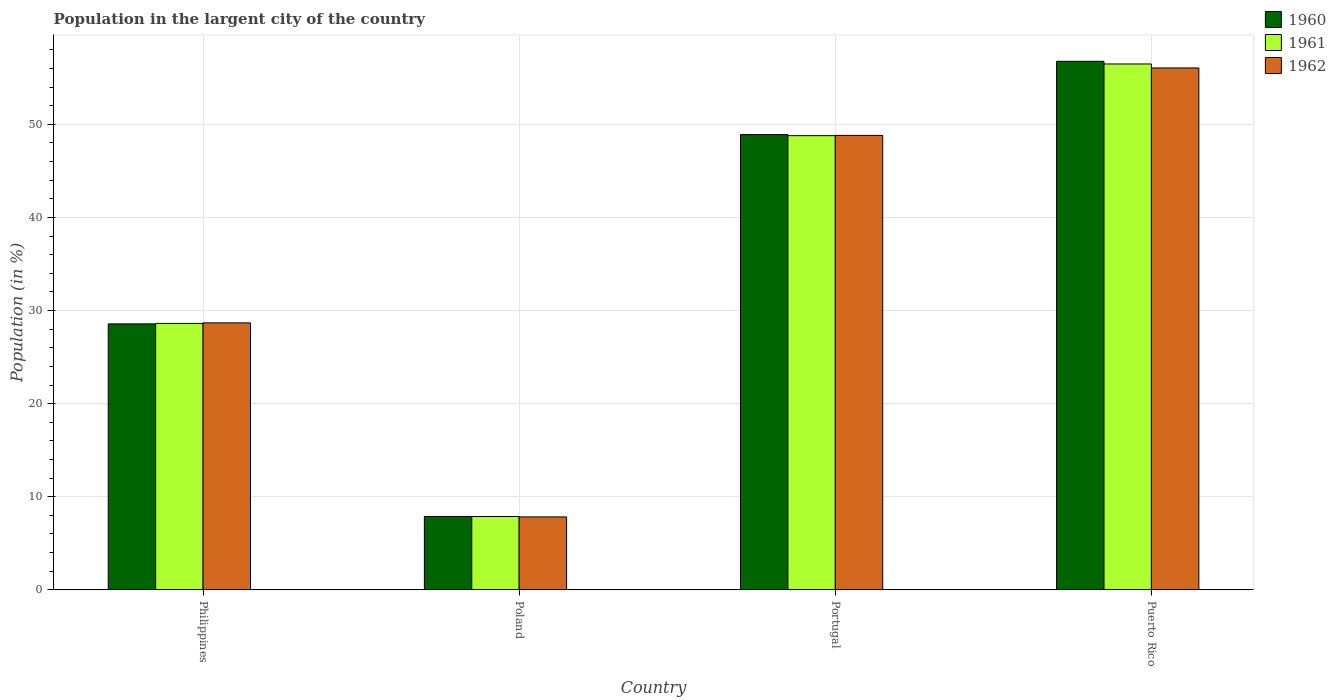How many different coloured bars are there?
Offer a very short reply. 3. How many groups of bars are there?
Offer a terse response. 4. Are the number of bars per tick equal to the number of legend labels?
Your answer should be compact. Yes. What is the label of the 4th group of bars from the left?
Provide a short and direct response. Puerto Rico. What is the percentage of population in the largent city in 1962 in Puerto Rico?
Offer a terse response. 56.05. Across all countries, what is the maximum percentage of population in the largent city in 1960?
Your answer should be very brief. 56.77. Across all countries, what is the minimum percentage of population in the largent city in 1960?
Make the answer very short. 7.88. In which country was the percentage of population in the largent city in 1960 maximum?
Offer a very short reply. Puerto Rico. What is the total percentage of population in the largent city in 1961 in the graph?
Provide a short and direct response. 141.75. What is the difference between the percentage of population in the largent city in 1960 in Portugal and that in Puerto Rico?
Offer a terse response. -7.87. What is the difference between the percentage of population in the largent city in 1960 in Poland and the percentage of population in the largent city in 1962 in Philippines?
Keep it short and to the point. -20.79. What is the average percentage of population in the largent city in 1961 per country?
Keep it short and to the point. 35.44. What is the difference between the percentage of population in the largent city of/in 1960 and percentage of population in the largent city of/in 1961 in Philippines?
Your response must be concise. -0.05. In how many countries, is the percentage of population in the largent city in 1961 greater than 32 %?
Give a very brief answer. 2. What is the ratio of the percentage of population in the largent city in 1961 in Poland to that in Puerto Rico?
Your answer should be compact. 0.14. Is the percentage of population in the largent city in 1960 in Poland less than that in Portugal?
Provide a succinct answer. Yes. Is the difference between the percentage of population in the largent city in 1960 in Poland and Portugal greater than the difference between the percentage of population in the largent city in 1961 in Poland and Portugal?
Offer a very short reply. No. What is the difference between the highest and the second highest percentage of population in the largent city in 1960?
Provide a short and direct response. 7.87. What is the difference between the highest and the lowest percentage of population in the largent city in 1960?
Keep it short and to the point. 48.88. In how many countries, is the percentage of population in the largent city in 1960 greater than the average percentage of population in the largent city in 1960 taken over all countries?
Your answer should be compact. 2. What does the 1st bar from the left in Portugal represents?
Your response must be concise. 1960. What does the 2nd bar from the right in Philippines represents?
Offer a very short reply. 1961. Are all the bars in the graph horizontal?
Offer a terse response. No. Are the values on the major ticks of Y-axis written in scientific E-notation?
Your response must be concise. No. Does the graph contain any zero values?
Offer a terse response. No. Does the graph contain grids?
Your answer should be very brief. Yes. What is the title of the graph?
Offer a terse response. Population in the largent city of the country. What is the Population (in %) of 1960 in Philippines?
Make the answer very short. 28.56. What is the Population (in %) in 1961 in Philippines?
Offer a very short reply. 28.62. What is the Population (in %) of 1962 in Philippines?
Offer a terse response. 28.67. What is the Population (in %) of 1960 in Poland?
Provide a short and direct response. 7.88. What is the Population (in %) in 1961 in Poland?
Provide a succinct answer. 7.88. What is the Population (in %) in 1962 in Poland?
Provide a short and direct response. 7.83. What is the Population (in %) of 1960 in Portugal?
Give a very brief answer. 48.89. What is the Population (in %) of 1961 in Portugal?
Keep it short and to the point. 48.78. What is the Population (in %) of 1962 in Portugal?
Provide a succinct answer. 48.81. What is the Population (in %) in 1960 in Puerto Rico?
Provide a short and direct response. 56.77. What is the Population (in %) of 1961 in Puerto Rico?
Your response must be concise. 56.48. What is the Population (in %) in 1962 in Puerto Rico?
Your answer should be compact. 56.05. Across all countries, what is the maximum Population (in %) in 1960?
Ensure brevity in your answer.  56.77. Across all countries, what is the maximum Population (in %) in 1961?
Offer a terse response. 56.48. Across all countries, what is the maximum Population (in %) of 1962?
Give a very brief answer. 56.05. Across all countries, what is the minimum Population (in %) in 1960?
Your answer should be compact. 7.88. Across all countries, what is the minimum Population (in %) of 1961?
Ensure brevity in your answer.  7.88. Across all countries, what is the minimum Population (in %) of 1962?
Keep it short and to the point. 7.83. What is the total Population (in %) in 1960 in the graph?
Your response must be concise. 142.11. What is the total Population (in %) in 1961 in the graph?
Make the answer very short. 141.75. What is the total Population (in %) of 1962 in the graph?
Keep it short and to the point. 141.36. What is the difference between the Population (in %) in 1960 in Philippines and that in Poland?
Give a very brief answer. 20.68. What is the difference between the Population (in %) in 1961 in Philippines and that in Poland?
Offer a terse response. 20.74. What is the difference between the Population (in %) of 1962 in Philippines and that in Poland?
Your answer should be very brief. 20.84. What is the difference between the Population (in %) in 1960 in Philippines and that in Portugal?
Ensure brevity in your answer.  -20.33. What is the difference between the Population (in %) of 1961 in Philippines and that in Portugal?
Ensure brevity in your answer.  -20.16. What is the difference between the Population (in %) in 1962 in Philippines and that in Portugal?
Give a very brief answer. -20.13. What is the difference between the Population (in %) of 1960 in Philippines and that in Puerto Rico?
Give a very brief answer. -28.2. What is the difference between the Population (in %) in 1961 in Philippines and that in Puerto Rico?
Your response must be concise. -27.86. What is the difference between the Population (in %) in 1962 in Philippines and that in Puerto Rico?
Your answer should be very brief. -27.38. What is the difference between the Population (in %) in 1960 in Poland and that in Portugal?
Offer a terse response. -41.01. What is the difference between the Population (in %) in 1961 in Poland and that in Portugal?
Ensure brevity in your answer.  -40.91. What is the difference between the Population (in %) in 1962 in Poland and that in Portugal?
Provide a succinct answer. -40.97. What is the difference between the Population (in %) in 1960 in Poland and that in Puerto Rico?
Give a very brief answer. -48.88. What is the difference between the Population (in %) of 1961 in Poland and that in Puerto Rico?
Your response must be concise. -48.6. What is the difference between the Population (in %) in 1962 in Poland and that in Puerto Rico?
Keep it short and to the point. -48.22. What is the difference between the Population (in %) of 1960 in Portugal and that in Puerto Rico?
Make the answer very short. -7.87. What is the difference between the Population (in %) of 1961 in Portugal and that in Puerto Rico?
Provide a short and direct response. -7.7. What is the difference between the Population (in %) of 1962 in Portugal and that in Puerto Rico?
Make the answer very short. -7.24. What is the difference between the Population (in %) of 1960 in Philippines and the Population (in %) of 1961 in Poland?
Provide a short and direct response. 20.69. What is the difference between the Population (in %) of 1960 in Philippines and the Population (in %) of 1962 in Poland?
Keep it short and to the point. 20.73. What is the difference between the Population (in %) of 1961 in Philippines and the Population (in %) of 1962 in Poland?
Ensure brevity in your answer.  20.78. What is the difference between the Population (in %) of 1960 in Philippines and the Population (in %) of 1961 in Portugal?
Give a very brief answer. -20.22. What is the difference between the Population (in %) in 1960 in Philippines and the Population (in %) in 1962 in Portugal?
Provide a short and direct response. -20.24. What is the difference between the Population (in %) in 1961 in Philippines and the Population (in %) in 1962 in Portugal?
Provide a succinct answer. -20.19. What is the difference between the Population (in %) in 1960 in Philippines and the Population (in %) in 1961 in Puerto Rico?
Your response must be concise. -27.91. What is the difference between the Population (in %) of 1960 in Philippines and the Population (in %) of 1962 in Puerto Rico?
Make the answer very short. -27.49. What is the difference between the Population (in %) of 1961 in Philippines and the Population (in %) of 1962 in Puerto Rico?
Your response must be concise. -27.43. What is the difference between the Population (in %) of 1960 in Poland and the Population (in %) of 1961 in Portugal?
Keep it short and to the point. -40.9. What is the difference between the Population (in %) of 1960 in Poland and the Population (in %) of 1962 in Portugal?
Your answer should be very brief. -40.92. What is the difference between the Population (in %) in 1961 in Poland and the Population (in %) in 1962 in Portugal?
Keep it short and to the point. -40.93. What is the difference between the Population (in %) of 1960 in Poland and the Population (in %) of 1961 in Puerto Rico?
Your answer should be very brief. -48.59. What is the difference between the Population (in %) of 1960 in Poland and the Population (in %) of 1962 in Puerto Rico?
Offer a very short reply. -48.17. What is the difference between the Population (in %) of 1961 in Poland and the Population (in %) of 1962 in Puerto Rico?
Offer a very short reply. -48.18. What is the difference between the Population (in %) of 1960 in Portugal and the Population (in %) of 1961 in Puerto Rico?
Your answer should be compact. -7.58. What is the difference between the Population (in %) in 1960 in Portugal and the Population (in %) in 1962 in Puerto Rico?
Offer a terse response. -7.16. What is the difference between the Population (in %) of 1961 in Portugal and the Population (in %) of 1962 in Puerto Rico?
Offer a terse response. -7.27. What is the average Population (in %) in 1960 per country?
Offer a terse response. 35.53. What is the average Population (in %) of 1961 per country?
Your answer should be very brief. 35.44. What is the average Population (in %) in 1962 per country?
Provide a succinct answer. 35.34. What is the difference between the Population (in %) of 1960 and Population (in %) of 1961 in Philippines?
Your answer should be very brief. -0.05. What is the difference between the Population (in %) in 1960 and Population (in %) in 1962 in Philippines?
Ensure brevity in your answer.  -0.11. What is the difference between the Population (in %) in 1961 and Population (in %) in 1962 in Philippines?
Your answer should be compact. -0.06. What is the difference between the Population (in %) in 1960 and Population (in %) in 1961 in Poland?
Offer a very short reply. 0.01. What is the difference between the Population (in %) in 1960 and Population (in %) in 1962 in Poland?
Make the answer very short. 0.05. What is the difference between the Population (in %) in 1961 and Population (in %) in 1962 in Poland?
Keep it short and to the point. 0.04. What is the difference between the Population (in %) of 1960 and Population (in %) of 1961 in Portugal?
Your response must be concise. 0.11. What is the difference between the Population (in %) of 1960 and Population (in %) of 1962 in Portugal?
Give a very brief answer. 0.09. What is the difference between the Population (in %) of 1961 and Population (in %) of 1962 in Portugal?
Provide a short and direct response. -0.03. What is the difference between the Population (in %) in 1960 and Population (in %) in 1961 in Puerto Rico?
Your answer should be very brief. 0.29. What is the difference between the Population (in %) in 1960 and Population (in %) in 1962 in Puerto Rico?
Ensure brevity in your answer.  0.71. What is the difference between the Population (in %) in 1961 and Population (in %) in 1962 in Puerto Rico?
Your answer should be compact. 0.43. What is the ratio of the Population (in %) of 1960 in Philippines to that in Poland?
Offer a terse response. 3.62. What is the ratio of the Population (in %) of 1961 in Philippines to that in Poland?
Your answer should be very brief. 3.63. What is the ratio of the Population (in %) of 1962 in Philippines to that in Poland?
Provide a short and direct response. 3.66. What is the ratio of the Population (in %) of 1960 in Philippines to that in Portugal?
Give a very brief answer. 0.58. What is the ratio of the Population (in %) in 1961 in Philippines to that in Portugal?
Provide a succinct answer. 0.59. What is the ratio of the Population (in %) in 1962 in Philippines to that in Portugal?
Provide a short and direct response. 0.59. What is the ratio of the Population (in %) of 1960 in Philippines to that in Puerto Rico?
Your answer should be very brief. 0.5. What is the ratio of the Population (in %) of 1961 in Philippines to that in Puerto Rico?
Provide a succinct answer. 0.51. What is the ratio of the Population (in %) of 1962 in Philippines to that in Puerto Rico?
Offer a terse response. 0.51. What is the ratio of the Population (in %) of 1960 in Poland to that in Portugal?
Your response must be concise. 0.16. What is the ratio of the Population (in %) in 1961 in Poland to that in Portugal?
Keep it short and to the point. 0.16. What is the ratio of the Population (in %) in 1962 in Poland to that in Portugal?
Offer a very short reply. 0.16. What is the ratio of the Population (in %) in 1960 in Poland to that in Puerto Rico?
Your response must be concise. 0.14. What is the ratio of the Population (in %) of 1961 in Poland to that in Puerto Rico?
Your response must be concise. 0.14. What is the ratio of the Population (in %) of 1962 in Poland to that in Puerto Rico?
Provide a short and direct response. 0.14. What is the ratio of the Population (in %) of 1960 in Portugal to that in Puerto Rico?
Make the answer very short. 0.86. What is the ratio of the Population (in %) in 1961 in Portugal to that in Puerto Rico?
Keep it short and to the point. 0.86. What is the ratio of the Population (in %) of 1962 in Portugal to that in Puerto Rico?
Offer a very short reply. 0.87. What is the difference between the highest and the second highest Population (in %) of 1960?
Your answer should be compact. 7.87. What is the difference between the highest and the second highest Population (in %) of 1961?
Your answer should be compact. 7.7. What is the difference between the highest and the second highest Population (in %) of 1962?
Offer a very short reply. 7.24. What is the difference between the highest and the lowest Population (in %) in 1960?
Your answer should be very brief. 48.88. What is the difference between the highest and the lowest Population (in %) in 1961?
Offer a terse response. 48.6. What is the difference between the highest and the lowest Population (in %) of 1962?
Ensure brevity in your answer.  48.22. 